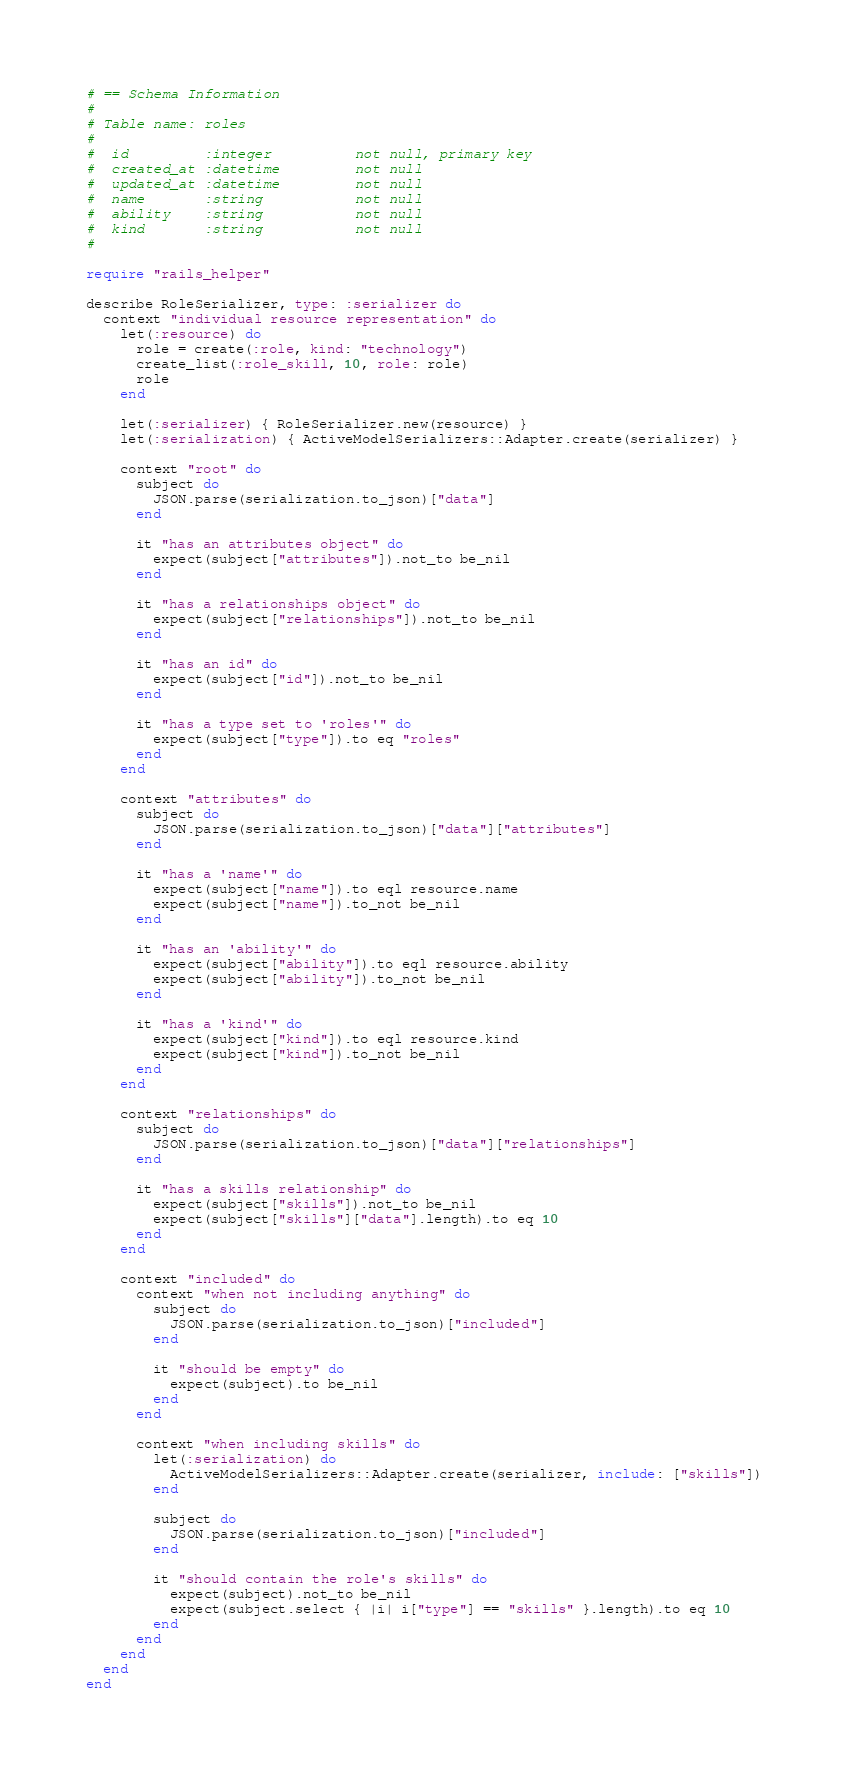Convert code to text. <code><loc_0><loc_0><loc_500><loc_500><_Ruby_># == Schema Information
#
# Table name: roles
#
#  id         :integer          not null, primary key
#  created_at :datetime         not null
#  updated_at :datetime         not null
#  name       :string           not null
#  ability    :string           not null
#  kind       :string           not null
#

require "rails_helper"

describe RoleSerializer, type: :serializer do
  context "individual resource representation" do
    let(:resource) do
      role = create(:role, kind: "technology")
      create_list(:role_skill, 10, role: role)
      role
    end

    let(:serializer) { RoleSerializer.new(resource) }
    let(:serialization) { ActiveModelSerializers::Adapter.create(serializer) }

    context "root" do
      subject do
        JSON.parse(serialization.to_json)["data"]
      end

      it "has an attributes object" do
        expect(subject["attributes"]).not_to be_nil
      end

      it "has a relationships object" do
        expect(subject["relationships"]).not_to be_nil
      end

      it "has an id" do
        expect(subject["id"]).not_to be_nil
      end

      it "has a type set to 'roles'" do
        expect(subject["type"]).to eq "roles"
      end
    end

    context "attributes" do
      subject do
        JSON.parse(serialization.to_json)["data"]["attributes"]
      end

      it "has a 'name'" do
        expect(subject["name"]).to eql resource.name
        expect(subject["name"]).to_not be_nil
      end

      it "has an 'ability'" do
        expect(subject["ability"]).to eql resource.ability
        expect(subject["ability"]).to_not be_nil
      end

      it "has a 'kind'" do
        expect(subject["kind"]).to eql resource.kind
        expect(subject["kind"]).to_not be_nil
      end
    end

    context "relationships" do
      subject do
        JSON.parse(serialization.to_json)["data"]["relationships"]
      end

      it "has a skills relationship" do
        expect(subject["skills"]).not_to be_nil
        expect(subject["skills"]["data"].length).to eq 10
      end
    end

    context "included" do
      context "when not including anything" do
        subject do
          JSON.parse(serialization.to_json)["included"]
        end

        it "should be empty" do
          expect(subject).to be_nil
        end
      end

      context "when including skills" do
        let(:serialization) do
          ActiveModelSerializers::Adapter.create(serializer, include: ["skills"])
        end

        subject do
          JSON.parse(serialization.to_json)["included"]
        end

        it "should contain the role's skills" do
          expect(subject).not_to be_nil
          expect(subject.select { |i| i["type"] == "skills" }.length).to eq 10
        end
      end
    end
  end
end
</code> 